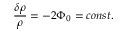<formula> <loc_0><loc_0><loc_500><loc_500>\frac { \delta \rho } { \rho } = - 2 \Phi _ { 0 } = c o n s t .</formula> 